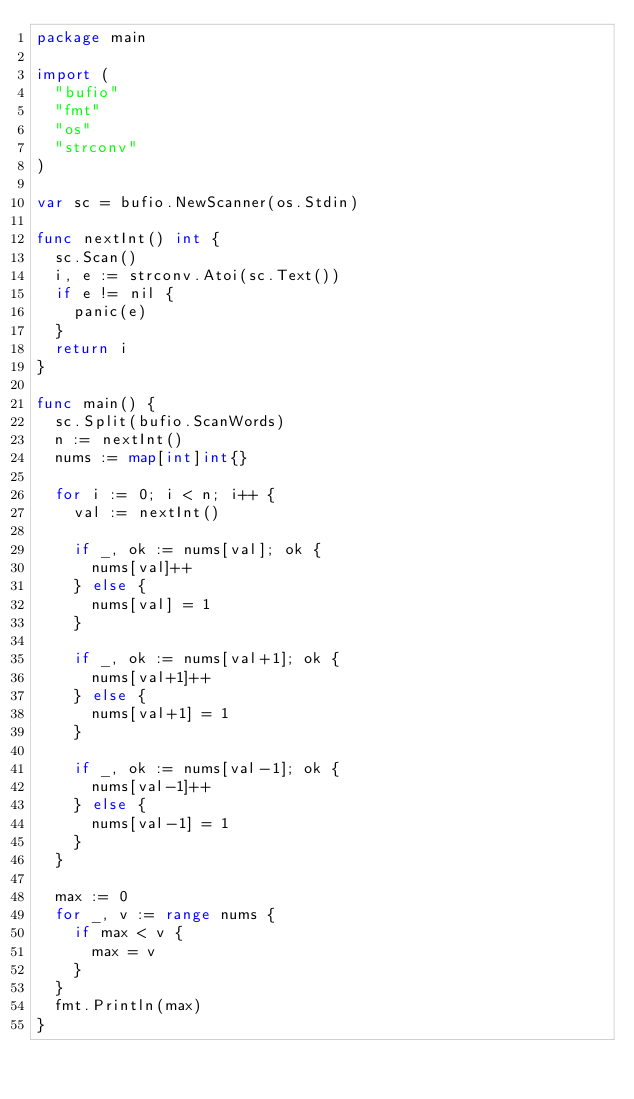<code> <loc_0><loc_0><loc_500><loc_500><_Go_>package main

import (
	"bufio"
	"fmt"
	"os"
	"strconv"
)

var sc = bufio.NewScanner(os.Stdin)

func nextInt() int {
	sc.Scan()
	i, e := strconv.Atoi(sc.Text())
	if e != nil {
		panic(e)
	}
	return i
}

func main() {
	sc.Split(bufio.ScanWords)
	n := nextInt()
	nums := map[int]int{}

	for i := 0; i < n; i++ {
		val := nextInt()

		if _, ok := nums[val]; ok {
			nums[val]++
		} else {
			nums[val] = 1
		}

		if _, ok := nums[val+1]; ok {
			nums[val+1]++
		} else {
			nums[val+1] = 1
		}

		if _, ok := nums[val-1]; ok {
			nums[val-1]++
		} else {
			nums[val-1] = 1
		}
	}

	max := 0
	for _, v := range nums {
		if max < v {
			max = v
		}
	}
	fmt.Println(max)
}</code> 